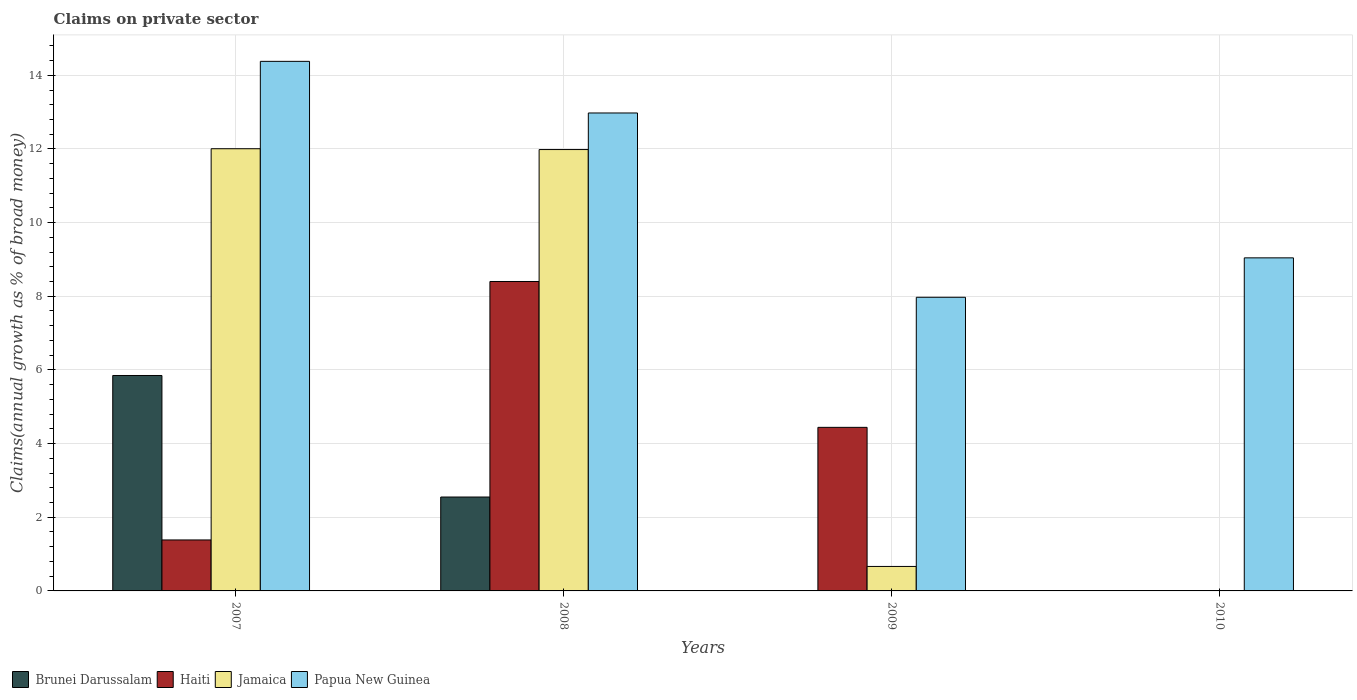Are the number of bars on each tick of the X-axis equal?
Provide a short and direct response. No. How many bars are there on the 2nd tick from the left?
Offer a very short reply. 4. How many bars are there on the 4th tick from the right?
Ensure brevity in your answer.  4. What is the percentage of broad money claimed on private sector in Haiti in 2008?
Make the answer very short. 8.4. Across all years, what is the maximum percentage of broad money claimed on private sector in Brunei Darussalam?
Your response must be concise. 5.85. In which year was the percentage of broad money claimed on private sector in Haiti maximum?
Offer a terse response. 2008. What is the total percentage of broad money claimed on private sector in Papua New Guinea in the graph?
Your response must be concise. 44.37. What is the difference between the percentage of broad money claimed on private sector in Papua New Guinea in 2007 and that in 2009?
Offer a terse response. 6.41. What is the difference between the percentage of broad money claimed on private sector in Brunei Darussalam in 2008 and the percentage of broad money claimed on private sector in Papua New Guinea in 2009?
Make the answer very short. -5.42. What is the average percentage of broad money claimed on private sector in Haiti per year?
Your response must be concise. 3.56. In the year 2007, what is the difference between the percentage of broad money claimed on private sector in Jamaica and percentage of broad money claimed on private sector in Brunei Darussalam?
Your response must be concise. 6.16. What is the ratio of the percentage of broad money claimed on private sector in Papua New Guinea in 2007 to that in 2009?
Keep it short and to the point. 1.8. Is the percentage of broad money claimed on private sector in Papua New Guinea in 2007 less than that in 2008?
Your response must be concise. No. What is the difference between the highest and the second highest percentage of broad money claimed on private sector in Haiti?
Offer a terse response. 3.96. What is the difference between the highest and the lowest percentage of broad money claimed on private sector in Jamaica?
Ensure brevity in your answer.  12.01. Is the sum of the percentage of broad money claimed on private sector in Papua New Guinea in 2009 and 2010 greater than the maximum percentage of broad money claimed on private sector in Haiti across all years?
Provide a short and direct response. Yes. Is it the case that in every year, the sum of the percentage of broad money claimed on private sector in Haiti and percentage of broad money claimed on private sector in Papua New Guinea is greater than the sum of percentage of broad money claimed on private sector in Brunei Darussalam and percentage of broad money claimed on private sector in Jamaica?
Give a very brief answer. Yes. Are all the bars in the graph horizontal?
Make the answer very short. No. How many years are there in the graph?
Offer a very short reply. 4. Does the graph contain any zero values?
Offer a terse response. Yes. Does the graph contain grids?
Your answer should be very brief. Yes. Where does the legend appear in the graph?
Give a very brief answer. Bottom left. How are the legend labels stacked?
Your response must be concise. Horizontal. What is the title of the graph?
Provide a short and direct response. Claims on private sector. What is the label or title of the Y-axis?
Make the answer very short. Claims(annual growth as % of broad money). What is the Claims(annual growth as % of broad money) of Brunei Darussalam in 2007?
Your answer should be compact. 5.85. What is the Claims(annual growth as % of broad money) of Haiti in 2007?
Ensure brevity in your answer.  1.38. What is the Claims(annual growth as % of broad money) in Jamaica in 2007?
Provide a succinct answer. 12.01. What is the Claims(annual growth as % of broad money) in Papua New Guinea in 2007?
Ensure brevity in your answer.  14.38. What is the Claims(annual growth as % of broad money) of Brunei Darussalam in 2008?
Your answer should be compact. 2.55. What is the Claims(annual growth as % of broad money) in Haiti in 2008?
Your response must be concise. 8.4. What is the Claims(annual growth as % of broad money) of Jamaica in 2008?
Keep it short and to the point. 11.98. What is the Claims(annual growth as % of broad money) of Papua New Guinea in 2008?
Provide a short and direct response. 12.98. What is the Claims(annual growth as % of broad money) of Brunei Darussalam in 2009?
Give a very brief answer. 0. What is the Claims(annual growth as % of broad money) of Haiti in 2009?
Your response must be concise. 4.44. What is the Claims(annual growth as % of broad money) in Jamaica in 2009?
Provide a short and direct response. 0.66. What is the Claims(annual growth as % of broad money) in Papua New Guinea in 2009?
Make the answer very short. 7.97. What is the Claims(annual growth as % of broad money) in Brunei Darussalam in 2010?
Your answer should be very brief. 0. What is the Claims(annual growth as % of broad money) of Haiti in 2010?
Provide a short and direct response. 0. What is the Claims(annual growth as % of broad money) in Jamaica in 2010?
Ensure brevity in your answer.  0. What is the Claims(annual growth as % of broad money) in Papua New Guinea in 2010?
Your response must be concise. 9.04. Across all years, what is the maximum Claims(annual growth as % of broad money) of Brunei Darussalam?
Ensure brevity in your answer.  5.85. Across all years, what is the maximum Claims(annual growth as % of broad money) of Haiti?
Ensure brevity in your answer.  8.4. Across all years, what is the maximum Claims(annual growth as % of broad money) of Jamaica?
Your answer should be compact. 12.01. Across all years, what is the maximum Claims(annual growth as % of broad money) of Papua New Guinea?
Offer a terse response. 14.38. Across all years, what is the minimum Claims(annual growth as % of broad money) in Haiti?
Keep it short and to the point. 0. Across all years, what is the minimum Claims(annual growth as % of broad money) in Jamaica?
Your response must be concise. 0. Across all years, what is the minimum Claims(annual growth as % of broad money) of Papua New Guinea?
Give a very brief answer. 7.97. What is the total Claims(annual growth as % of broad money) of Brunei Darussalam in the graph?
Keep it short and to the point. 8.4. What is the total Claims(annual growth as % of broad money) of Haiti in the graph?
Your response must be concise. 14.23. What is the total Claims(annual growth as % of broad money) in Jamaica in the graph?
Your response must be concise. 24.65. What is the total Claims(annual growth as % of broad money) in Papua New Guinea in the graph?
Ensure brevity in your answer.  44.37. What is the difference between the Claims(annual growth as % of broad money) in Brunei Darussalam in 2007 and that in 2008?
Keep it short and to the point. 3.3. What is the difference between the Claims(annual growth as % of broad money) in Haiti in 2007 and that in 2008?
Provide a succinct answer. -7.02. What is the difference between the Claims(annual growth as % of broad money) of Jamaica in 2007 and that in 2008?
Your response must be concise. 0.02. What is the difference between the Claims(annual growth as % of broad money) of Papua New Guinea in 2007 and that in 2008?
Give a very brief answer. 1.4. What is the difference between the Claims(annual growth as % of broad money) of Haiti in 2007 and that in 2009?
Provide a short and direct response. -3.06. What is the difference between the Claims(annual growth as % of broad money) in Jamaica in 2007 and that in 2009?
Provide a succinct answer. 11.34. What is the difference between the Claims(annual growth as % of broad money) in Papua New Guinea in 2007 and that in 2009?
Your answer should be very brief. 6.41. What is the difference between the Claims(annual growth as % of broad money) in Papua New Guinea in 2007 and that in 2010?
Give a very brief answer. 5.33. What is the difference between the Claims(annual growth as % of broad money) of Haiti in 2008 and that in 2009?
Your answer should be compact. 3.96. What is the difference between the Claims(annual growth as % of broad money) of Jamaica in 2008 and that in 2009?
Offer a terse response. 11.32. What is the difference between the Claims(annual growth as % of broad money) of Papua New Guinea in 2008 and that in 2009?
Keep it short and to the point. 5. What is the difference between the Claims(annual growth as % of broad money) of Papua New Guinea in 2008 and that in 2010?
Ensure brevity in your answer.  3.93. What is the difference between the Claims(annual growth as % of broad money) in Papua New Guinea in 2009 and that in 2010?
Your answer should be compact. -1.07. What is the difference between the Claims(annual growth as % of broad money) of Brunei Darussalam in 2007 and the Claims(annual growth as % of broad money) of Haiti in 2008?
Your answer should be very brief. -2.55. What is the difference between the Claims(annual growth as % of broad money) of Brunei Darussalam in 2007 and the Claims(annual growth as % of broad money) of Jamaica in 2008?
Your answer should be compact. -6.13. What is the difference between the Claims(annual growth as % of broad money) of Brunei Darussalam in 2007 and the Claims(annual growth as % of broad money) of Papua New Guinea in 2008?
Your response must be concise. -7.13. What is the difference between the Claims(annual growth as % of broad money) in Haiti in 2007 and the Claims(annual growth as % of broad money) in Jamaica in 2008?
Offer a terse response. -10.6. What is the difference between the Claims(annual growth as % of broad money) of Haiti in 2007 and the Claims(annual growth as % of broad money) of Papua New Guinea in 2008?
Provide a short and direct response. -11.59. What is the difference between the Claims(annual growth as % of broad money) of Jamaica in 2007 and the Claims(annual growth as % of broad money) of Papua New Guinea in 2008?
Provide a short and direct response. -0.97. What is the difference between the Claims(annual growth as % of broad money) of Brunei Darussalam in 2007 and the Claims(annual growth as % of broad money) of Haiti in 2009?
Ensure brevity in your answer.  1.41. What is the difference between the Claims(annual growth as % of broad money) in Brunei Darussalam in 2007 and the Claims(annual growth as % of broad money) in Jamaica in 2009?
Your response must be concise. 5.18. What is the difference between the Claims(annual growth as % of broad money) in Brunei Darussalam in 2007 and the Claims(annual growth as % of broad money) in Papua New Guinea in 2009?
Your answer should be compact. -2.12. What is the difference between the Claims(annual growth as % of broad money) of Haiti in 2007 and the Claims(annual growth as % of broad money) of Jamaica in 2009?
Your answer should be compact. 0.72. What is the difference between the Claims(annual growth as % of broad money) of Haiti in 2007 and the Claims(annual growth as % of broad money) of Papua New Guinea in 2009?
Offer a very short reply. -6.59. What is the difference between the Claims(annual growth as % of broad money) in Jamaica in 2007 and the Claims(annual growth as % of broad money) in Papua New Guinea in 2009?
Make the answer very short. 4.03. What is the difference between the Claims(annual growth as % of broad money) in Brunei Darussalam in 2007 and the Claims(annual growth as % of broad money) in Papua New Guinea in 2010?
Your answer should be very brief. -3.19. What is the difference between the Claims(annual growth as % of broad money) in Haiti in 2007 and the Claims(annual growth as % of broad money) in Papua New Guinea in 2010?
Provide a succinct answer. -7.66. What is the difference between the Claims(annual growth as % of broad money) of Jamaica in 2007 and the Claims(annual growth as % of broad money) of Papua New Guinea in 2010?
Keep it short and to the point. 2.96. What is the difference between the Claims(annual growth as % of broad money) in Brunei Darussalam in 2008 and the Claims(annual growth as % of broad money) in Haiti in 2009?
Offer a terse response. -1.89. What is the difference between the Claims(annual growth as % of broad money) in Brunei Darussalam in 2008 and the Claims(annual growth as % of broad money) in Jamaica in 2009?
Provide a short and direct response. 1.89. What is the difference between the Claims(annual growth as % of broad money) of Brunei Darussalam in 2008 and the Claims(annual growth as % of broad money) of Papua New Guinea in 2009?
Your response must be concise. -5.42. What is the difference between the Claims(annual growth as % of broad money) of Haiti in 2008 and the Claims(annual growth as % of broad money) of Jamaica in 2009?
Ensure brevity in your answer.  7.74. What is the difference between the Claims(annual growth as % of broad money) in Haiti in 2008 and the Claims(annual growth as % of broad money) in Papua New Guinea in 2009?
Your answer should be very brief. 0.43. What is the difference between the Claims(annual growth as % of broad money) of Jamaica in 2008 and the Claims(annual growth as % of broad money) of Papua New Guinea in 2009?
Keep it short and to the point. 4.01. What is the difference between the Claims(annual growth as % of broad money) of Brunei Darussalam in 2008 and the Claims(annual growth as % of broad money) of Papua New Guinea in 2010?
Provide a succinct answer. -6.49. What is the difference between the Claims(annual growth as % of broad money) of Haiti in 2008 and the Claims(annual growth as % of broad money) of Papua New Guinea in 2010?
Provide a short and direct response. -0.64. What is the difference between the Claims(annual growth as % of broad money) in Jamaica in 2008 and the Claims(annual growth as % of broad money) in Papua New Guinea in 2010?
Provide a short and direct response. 2.94. What is the difference between the Claims(annual growth as % of broad money) in Haiti in 2009 and the Claims(annual growth as % of broad money) in Papua New Guinea in 2010?
Keep it short and to the point. -4.6. What is the difference between the Claims(annual growth as % of broad money) in Jamaica in 2009 and the Claims(annual growth as % of broad money) in Papua New Guinea in 2010?
Ensure brevity in your answer.  -8.38. What is the average Claims(annual growth as % of broad money) of Brunei Darussalam per year?
Offer a very short reply. 2.1. What is the average Claims(annual growth as % of broad money) of Haiti per year?
Your answer should be very brief. 3.56. What is the average Claims(annual growth as % of broad money) in Jamaica per year?
Offer a very short reply. 6.16. What is the average Claims(annual growth as % of broad money) of Papua New Guinea per year?
Provide a short and direct response. 11.09. In the year 2007, what is the difference between the Claims(annual growth as % of broad money) of Brunei Darussalam and Claims(annual growth as % of broad money) of Haiti?
Provide a succinct answer. 4.46. In the year 2007, what is the difference between the Claims(annual growth as % of broad money) in Brunei Darussalam and Claims(annual growth as % of broad money) in Jamaica?
Offer a very short reply. -6.16. In the year 2007, what is the difference between the Claims(annual growth as % of broad money) of Brunei Darussalam and Claims(annual growth as % of broad money) of Papua New Guinea?
Give a very brief answer. -8.53. In the year 2007, what is the difference between the Claims(annual growth as % of broad money) of Haiti and Claims(annual growth as % of broad money) of Jamaica?
Offer a terse response. -10.62. In the year 2007, what is the difference between the Claims(annual growth as % of broad money) in Haiti and Claims(annual growth as % of broad money) in Papua New Guinea?
Ensure brevity in your answer.  -12.99. In the year 2007, what is the difference between the Claims(annual growth as % of broad money) in Jamaica and Claims(annual growth as % of broad money) in Papua New Guinea?
Your answer should be compact. -2.37. In the year 2008, what is the difference between the Claims(annual growth as % of broad money) in Brunei Darussalam and Claims(annual growth as % of broad money) in Haiti?
Provide a succinct answer. -5.85. In the year 2008, what is the difference between the Claims(annual growth as % of broad money) of Brunei Darussalam and Claims(annual growth as % of broad money) of Jamaica?
Offer a terse response. -9.43. In the year 2008, what is the difference between the Claims(annual growth as % of broad money) in Brunei Darussalam and Claims(annual growth as % of broad money) in Papua New Guinea?
Ensure brevity in your answer.  -10.43. In the year 2008, what is the difference between the Claims(annual growth as % of broad money) in Haiti and Claims(annual growth as % of broad money) in Jamaica?
Offer a terse response. -3.58. In the year 2008, what is the difference between the Claims(annual growth as % of broad money) in Haiti and Claims(annual growth as % of broad money) in Papua New Guinea?
Your answer should be very brief. -4.58. In the year 2008, what is the difference between the Claims(annual growth as % of broad money) in Jamaica and Claims(annual growth as % of broad money) in Papua New Guinea?
Ensure brevity in your answer.  -0.99. In the year 2009, what is the difference between the Claims(annual growth as % of broad money) in Haiti and Claims(annual growth as % of broad money) in Jamaica?
Your answer should be very brief. 3.78. In the year 2009, what is the difference between the Claims(annual growth as % of broad money) of Haiti and Claims(annual growth as % of broad money) of Papua New Guinea?
Make the answer very short. -3.53. In the year 2009, what is the difference between the Claims(annual growth as % of broad money) of Jamaica and Claims(annual growth as % of broad money) of Papua New Guinea?
Keep it short and to the point. -7.31. What is the ratio of the Claims(annual growth as % of broad money) of Brunei Darussalam in 2007 to that in 2008?
Your answer should be compact. 2.29. What is the ratio of the Claims(annual growth as % of broad money) in Haiti in 2007 to that in 2008?
Provide a short and direct response. 0.16. What is the ratio of the Claims(annual growth as % of broad money) in Papua New Guinea in 2007 to that in 2008?
Make the answer very short. 1.11. What is the ratio of the Claims(annual growth as % of broad money) in Haiti in 2007 to that in 2009?
Provide a succinct answer. 0.31. What is the ratio of the Claims(annual growth as % of broad money) of Jamaica in 2007 to that in 2009?
Ensure brevity in your answer.  18.07. What is the ratio of the Claims(annual growth as % of broad money) in Papua New Guinea in 2007 to that in 2009?
Give a very brief answer. 1.8. What is the ratio of the Claims(annual growth as % of broad money) in Papua New Guinea in 2007 to that in 2010?
Ensure brevity in your answer.  1.59. What is the ratio of the Claims(annual growth as % of broad money) of Haiti in 2008 to that in 2009?
Offer a terse response. 1.89. What is the ratio of the Claims(annual growth as % of broad money) of Jamaica in 2008 to that in 2009?
Provide a short and direct response. 18.03. What is the ratio of the Claims(annual growth as % of broad money) of Papua New Guinea in 2008 to that in 2009?
Your response must be concise. 1.63. What is the ratio of the Claims(annual growth as % of broad money) of Papua New Guinea in 2008 to that in 2010?
Make the answer very short. 1.43. What is the ratio of the Claims(annual growth as % of broad money) of Papua New Guinea in 2009 to that in 2010?
Your answer should be very brief. 0.88. What is the difference between the highest and the second highest Claims(annual growth as % of broad money) in Haiti?
Make the answer very short. 3.96. What is the difference between the highest and the second highest Claims(annual growth as % of broad money) of Jamaica?
Make the answer very short. 0.02. What is the difference between the highest and the second highest Claims(annual growth as % of broad money) in Papua New Guinea?
Your answer should be compact. 1.4. What is the difference between the highest and the lowest Claims(annual growth as % of broad money) in Brunei Darussalam?
Provide a succinct answer. 5.85. What is the difference between the highest and the lowest Claims(annual growth as % of broad money) of Haiti?
Offer a very short reply. 8.4. What is the difference between the highest and the lowest Claims(annual growth as % of broad money) in Jamaica?
Ensure brevity in your answer.  12.01. What is the difference between the highest and the lowest Claims(annual growth as % of broad money) of Papua New Guinea?
Provide a succinct answer. 6.41. 